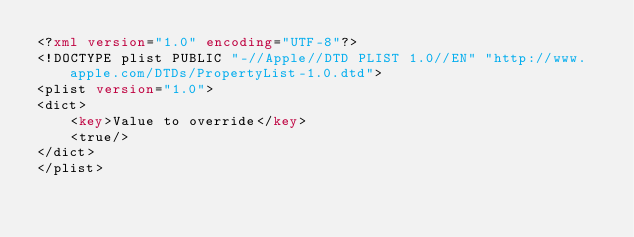Convert code to text. <code><loc_0><loc_0><loc_500><loc_500><_XML_><?xml version="1.0" encoding="UTF-8"?>
<!DOCTYPE plist PUBLIC "-//Apple//DTD PLIST 1.0//EN" "http://www.apple.com/DTDs/PropertyList-1.0.dtd">
<plist version="1.0">
<dict>
	<key>Value to override</key>
	<true/>
</dict>
</plist>
</code> 